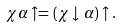<formula> <loc_0><loc_0><loc_500><loc_500>\chi \alpha \uparrow = ( \chi \downarrow \, \alpha ) \uparrow .</formula> 